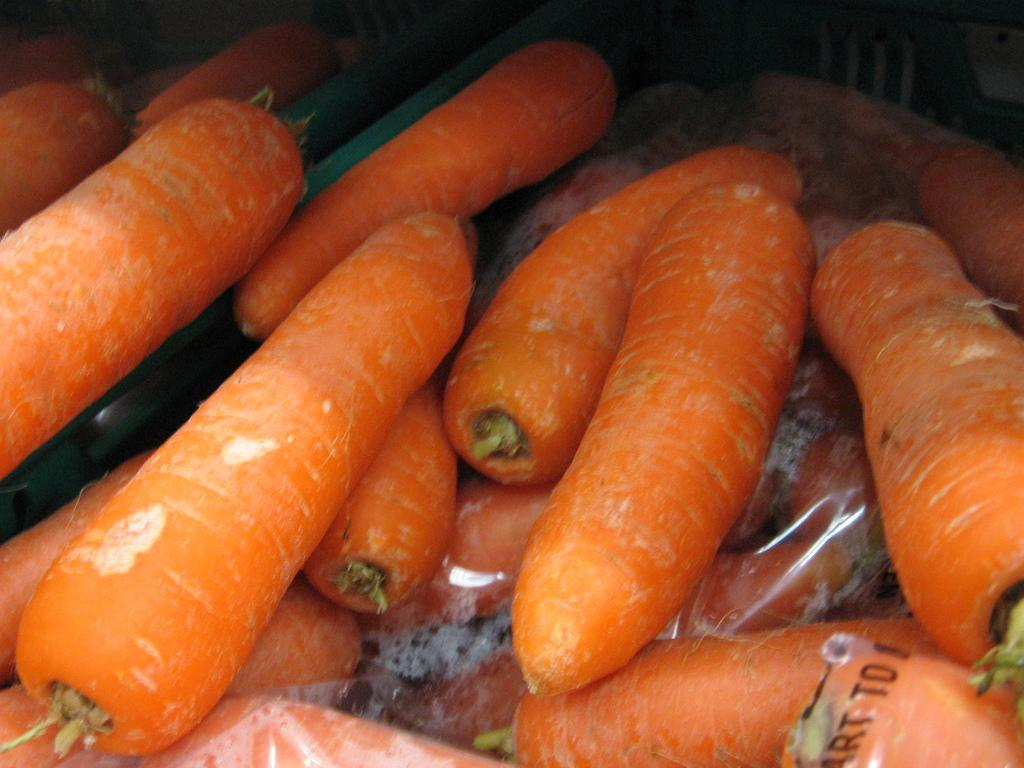What is located in the center of the image? There are carrots in the center of the image. What type of drain can be seen in the image? There is no drain present in the image; it features carrots in the center. 